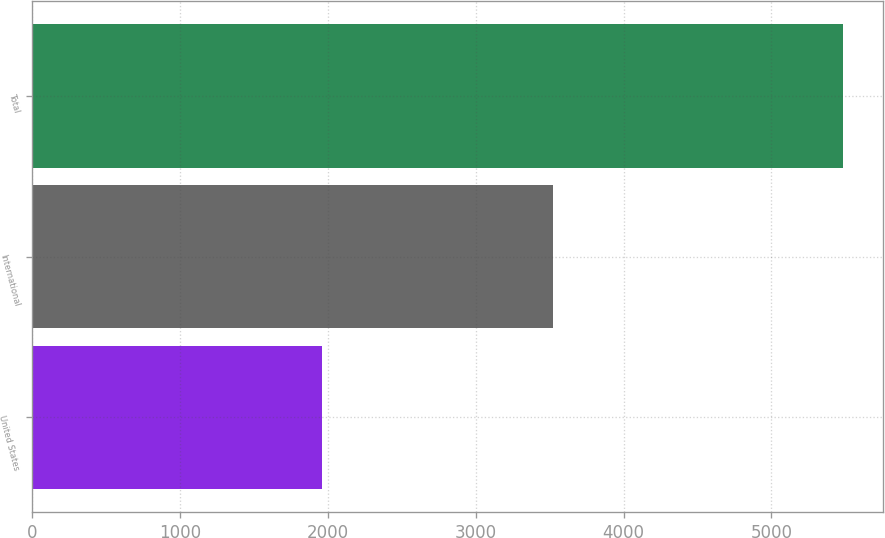<chart> <loc_0><loc_0><loc_500><loc_500><bar_chart><fcel>United States<fcel>International<fcel>Total<nl><fcel>1962.1<fcel>3521.6<fcel>5483.7<nl></chart> 